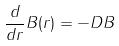<formula> <loc_0><loc_0><loc_500><loc_500>\frac { d } { d r } B ( r ) = - D B</formula> 